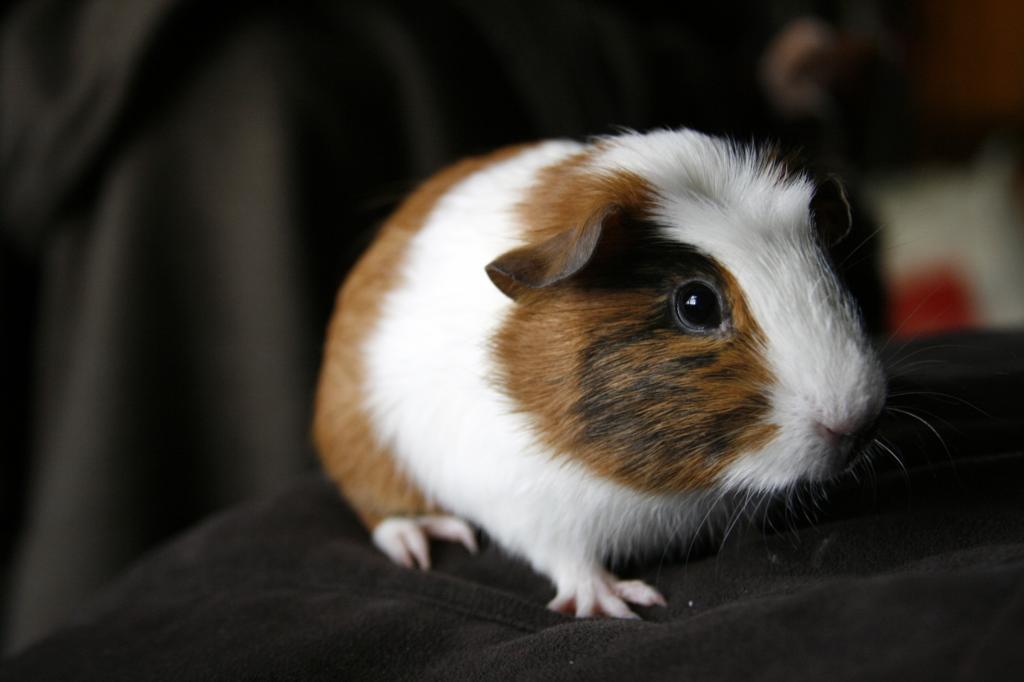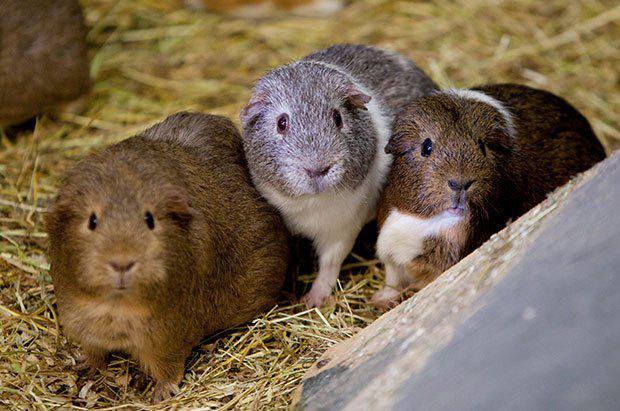The first image is the image on the left, the second image is the image on the right. Examine the images to the left and right. Is the description "There are three guinea pigs huddled up closely together in one picture of both pairs." accurate? Answer yes or no. Yes. The first image is the image on the left, the second image is the image on the right. Evaluate the accuracy of this statement regarding the images: "All of the four hamsters have different color patterns and none of them are eating.". Is it true? Answer yes or no. Yes. 